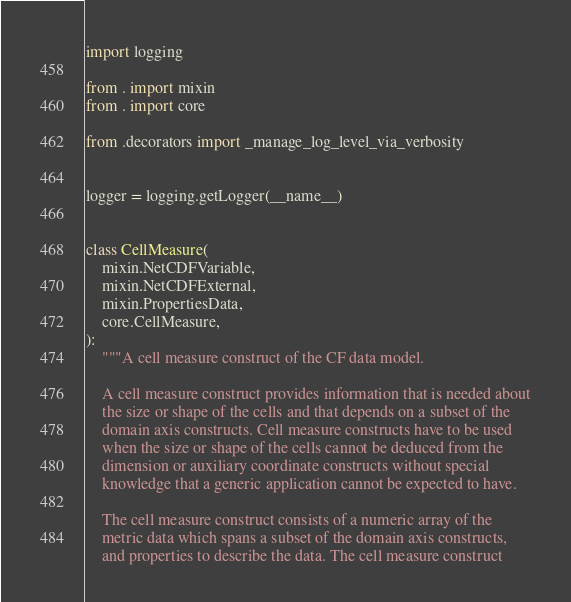<code> <loc_0><loc_0><loc_500><loc_500><_Python_>import logging

from . import mixin
from . import core

from .decorators import _manage_log_level_via_verbosity


logger = logging.getLogger(__name__)


class CellMeasure(
    mixin.NetCDFVariable,
    mixin.NetCDFExternal,
    mixin.PropertiesData,
    core.CellMeasure,
):
    """A cell measure construct of the CF data model.

    A cell measure construct provides information that is needed about
    the size or shape of the cells and that depends on a subset of the
    domain axis constructs. Cell measure constructs have to be used
    when the size or shape of the cells cannot be deduced from the
    dimension or auxiliary coordinate constructs without special
    knowledge that a generic application cannot be expected to have.

    The cell measure construct consists of a numeric array of the
    metric data which spans a subset of the domain axis constructs,
    and properties to describe the data. The cell measure construct</code> 